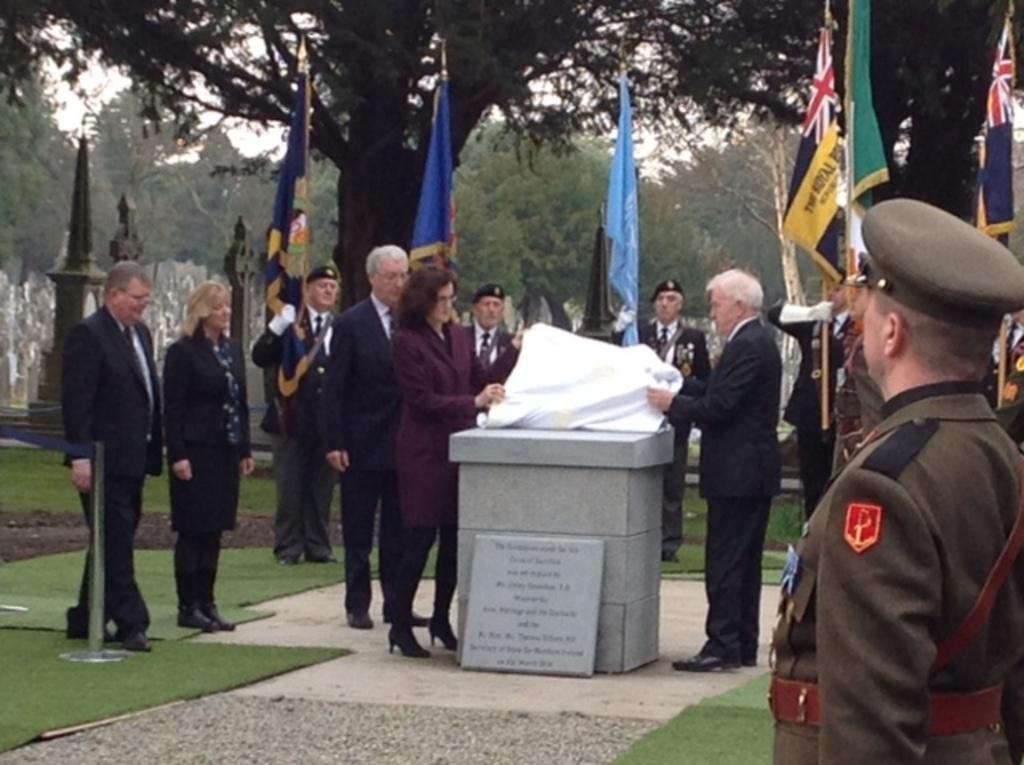What can be seen in the foreground of the picture? In the foreground of the picture, there are people, flags, mats, and a cornerstone. What is the condition of the sky in the picture? The sky is cloudy in the picture. What can be seen in the background of the picture? In the background of the picture, there are trees and gravestones. How does the brake system work on the cub in the picture? There is no brake system or cub present in the image. What is the digestion process of the trees in the background? The image does not depict the digestion process of the trees; it only shows their presence in the background. 